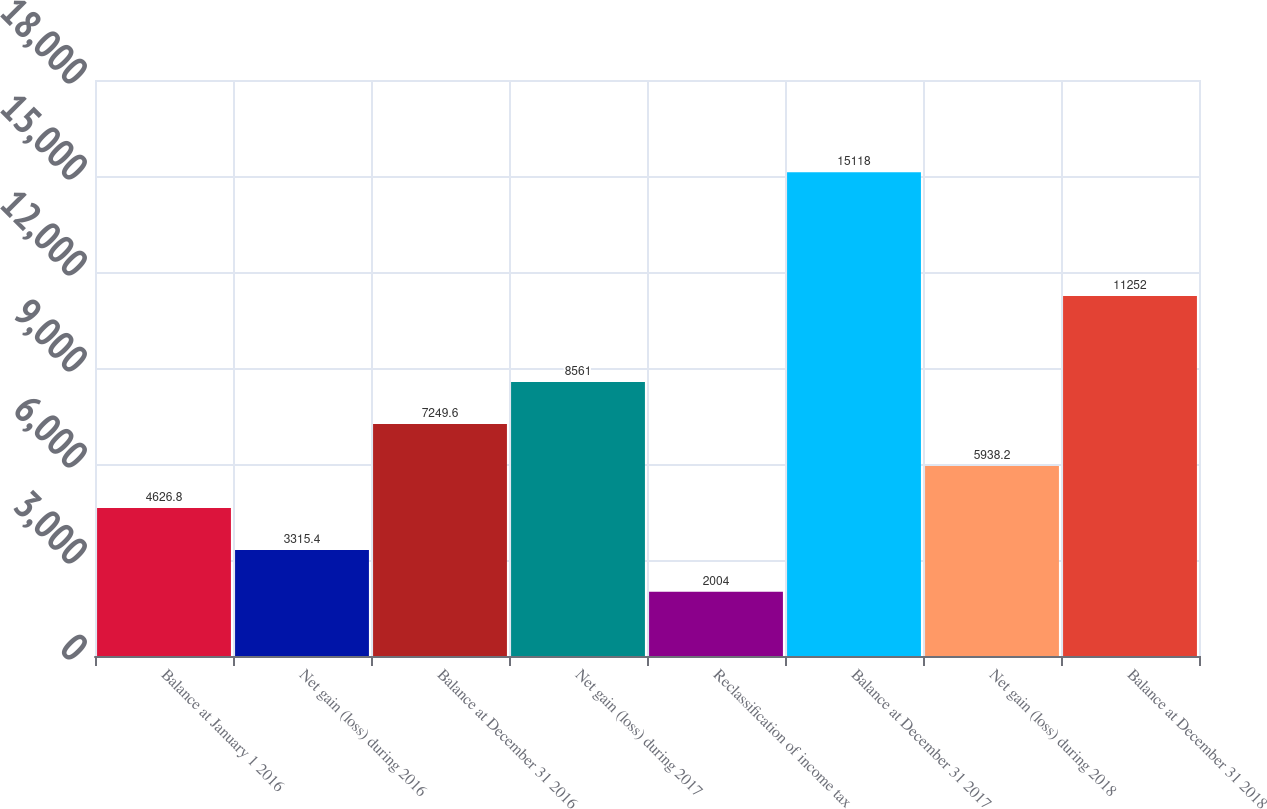Convert chart to OTSL. <chart><loc_0><loc_0><loc_500><loc_500><bar_chart><fcel>Balance at January 1 2016<fcel>Net gain (loss) during 2016<fcel>Balance at December 31 2016<fcel>Net gain (loss) during 2017<fcel>Reclassification of income tax<fcel>Balance at December 31 2017<fcel>Net gain (loss) during 2018<fcel>Balance at December 31 2018<nl><fcel>4626.8<fcel>3315.4<fcel>7249.6<fcel>8561<fcel>2004<fcel>15118<fcel>5938.2<fcel>11252<nl></chart> 